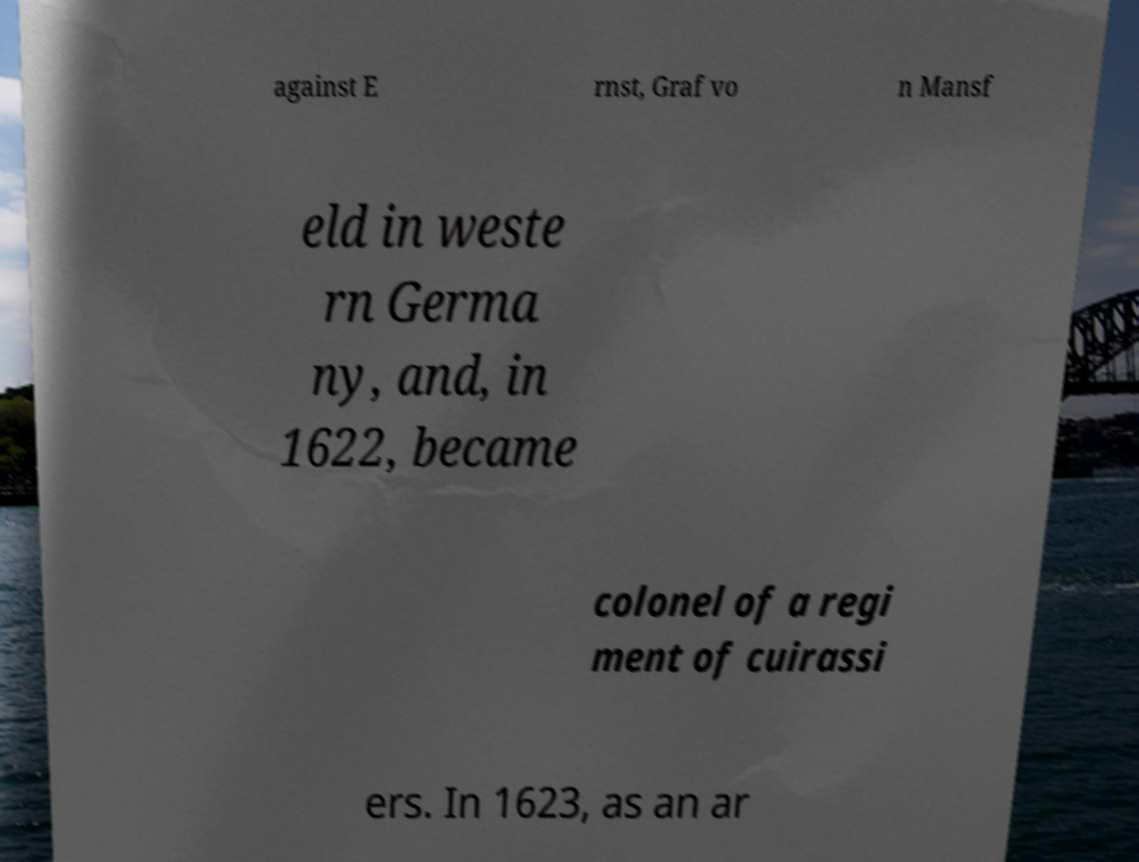Please identify and transcribe the text found in this image. against E rnst, Graf vo n Mansf eld in weste rn Germa ny, and, in 1622, became colonel of a regi ment of cuirassi ers. In 1623, as an ar 